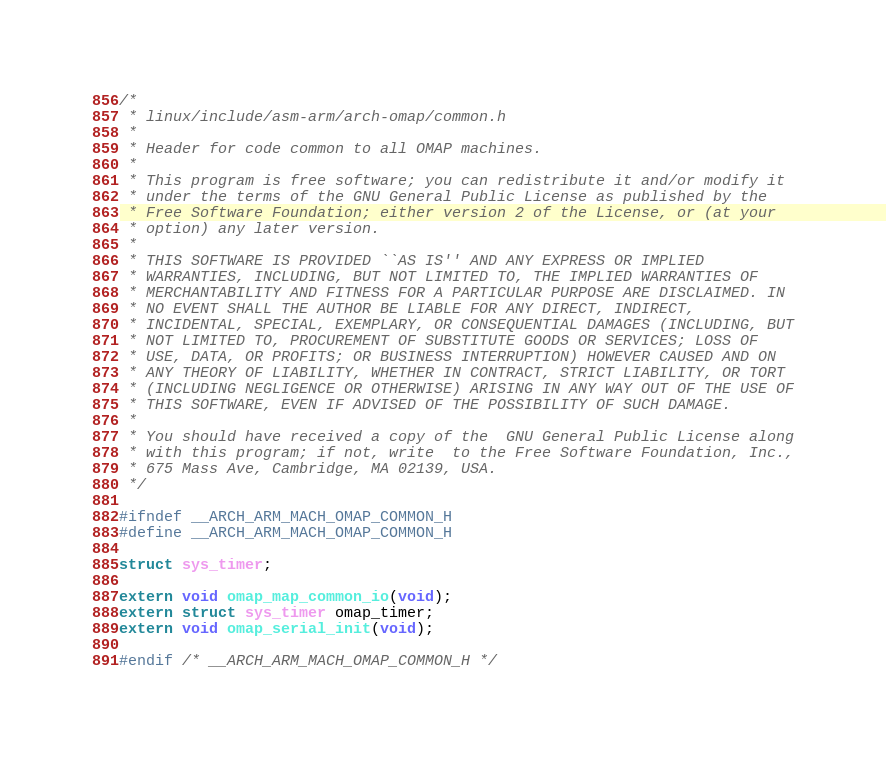Convert code to text. <code><loc_0><loc_0><loc_500><loc_500><_C_>/*
 * linux/include/asm-arm/arch-omap/common.h
 *
 * Header for code common to all OMAP machines.
 *
 * This program is free software; you can redistribute it and/or modify it
 * under the terms of the GNU General Public License as published by the
 * Free Software Foundation; either version 2 of the License, or (at your
 * option) any later version.
 *
 * THIS SOFTWARE IS PROVIDED ``AS IS'' AND ANY EXPRESS OR IMPLIED
 * WARRANTIES, INCLUDING, BUT NOT LIMITED TO, THE IMPLIED WARRANTIES OF
 * MERCHANTABILITY AND FITNESS FOR A PARTICULAR PURPOSE ARE DISCLAIMED. IN
 * NO EVENT SHALL THE AUTHOR BE LIABLE FOR ANY DIRECT, INDIRECT,
 * INCIDENTAL, SPECIAL, EXEMPLARY, OR CONSEQUENTIAL DAMAGES (INCLUDING, BUT
 * NOT LIMITED TO, PROCUREMENT OF SUBSTITUTE GOODS OR SERVICES; LOSS OF
 * USE, DATA, OR PROFITS; OR BUSINESS INTERRUPTION) HOWEVER CAUSED AND ON
 * ANY THEORY OF LIABILITY, WHETHER IN CONTRACT, STRICT LIABILITY, OR TORT
 * (INCLUDING NEGLIGENCE OR OTHERWISE) ARISING IN ANY WAY OUT OF THE USE OF
 * THIS SOFTWARE, EVEN IF ADVISED OF THE POSSIBILITY OF SUCH DAMAGE.
 *
 * You should have received a copy of the  GNU General Public License along
 * with this program; if not, write  to the Free Software Foundation, Inc.,
 * 675 Mass Ave, Cambridge, MA 02139, USA.
 */

#ifndef __ARCH_ARM_MACH_OMAP_COMMON_H
#define __ARCH_ARM_MACH_OMAP_COMMON_H

struct sys_timer;

extern void omap_map_common_io(void);
extern struct sys_timer omap_timer;
extern void omap_serial_init(void);

#endif /* __ARCH_ARM_MACH_OMAP_COMMON_H */
</code> 